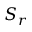Convert formula to latex. <formula><loc_0><loc_0><loc_500><loc_500>S _ { r }</formula> 